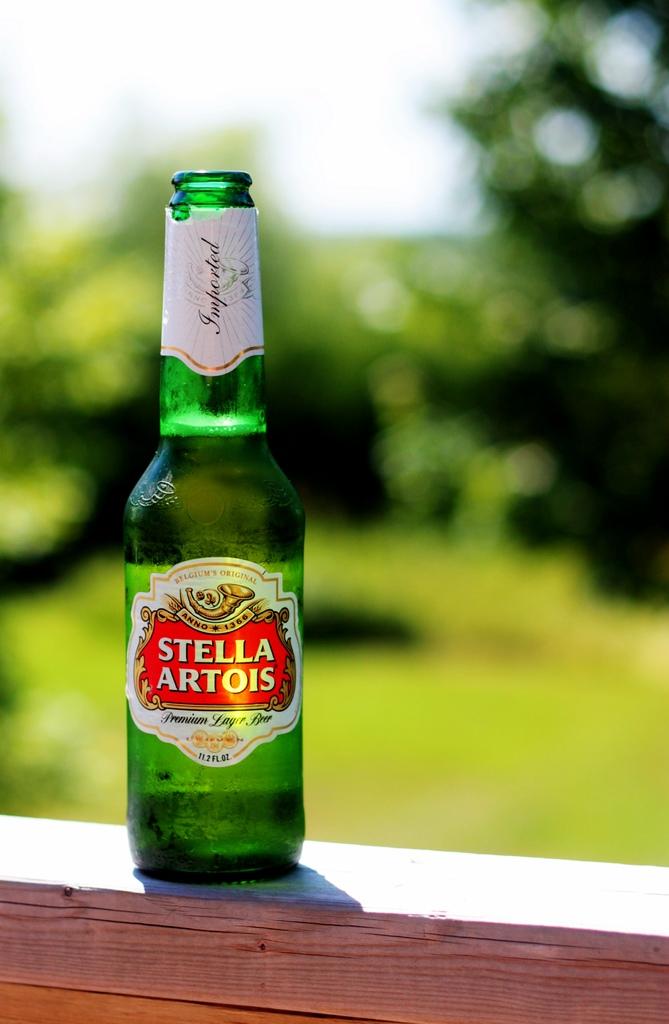How many fluid ounces is in this bottle?
Your answer should be compact. 11.2. 